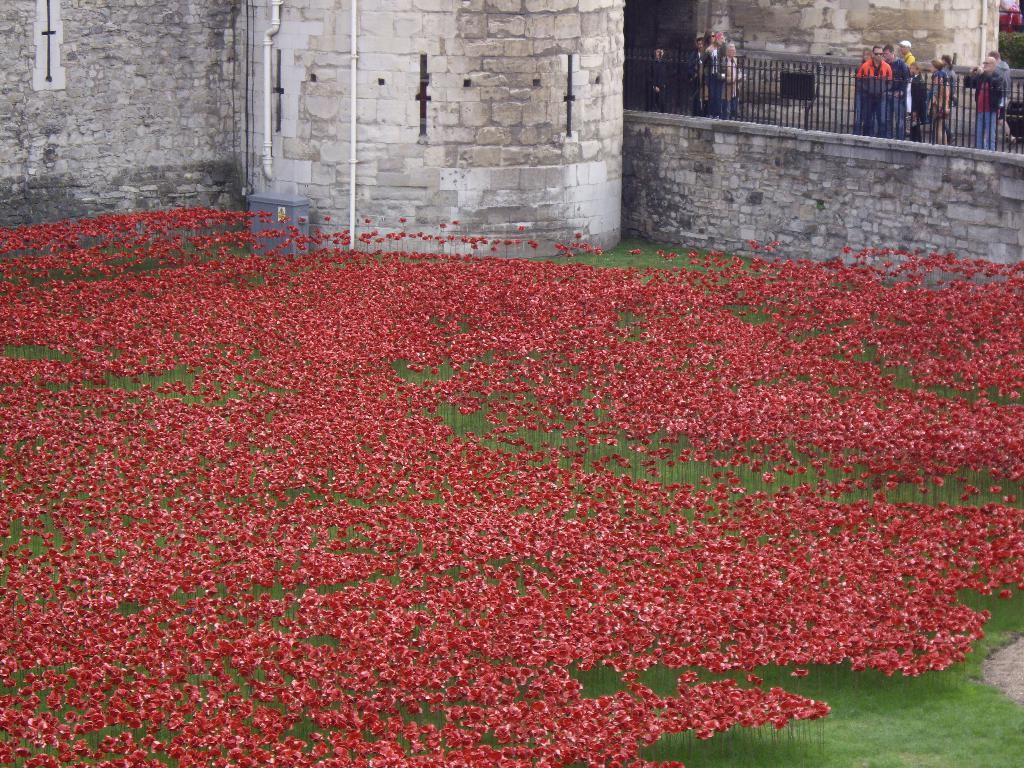What type of plants can be seen in the image? There are flowers in the image. What structure is visible in the background of the image? There is a fort in the background of the image. What feature is present in the foreground of the image? There is a railing in the image. Can you describe the people in the image? There are people standing behind the railing. How many dimes are scattered among the flowers in the image? There are no dimes present in the image; it features flowers, a fort in the background, a railing, and people standing behind the railing. 